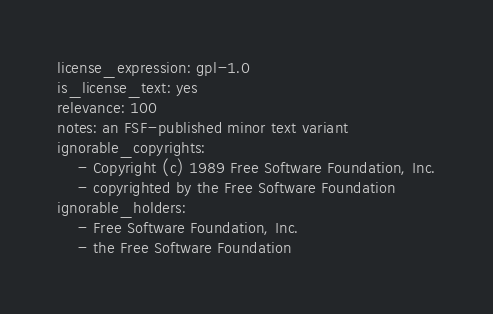<code> <loc_0><loc_0><loc_500><loc_500><_YAML_>license_expression: gpl-1.0
is_license_text: yes
relevance: 100
notes: an FSF-published minor text variant
ignorable_copyrights:
    - Copyright (c) 1989 Free Software Foundation, Inc.
    - copyrighted by the Free Software Foundation
ignorable_holders:
    - Free Software Foundation, Inc.
    - the Free Software Foundation
</code> 